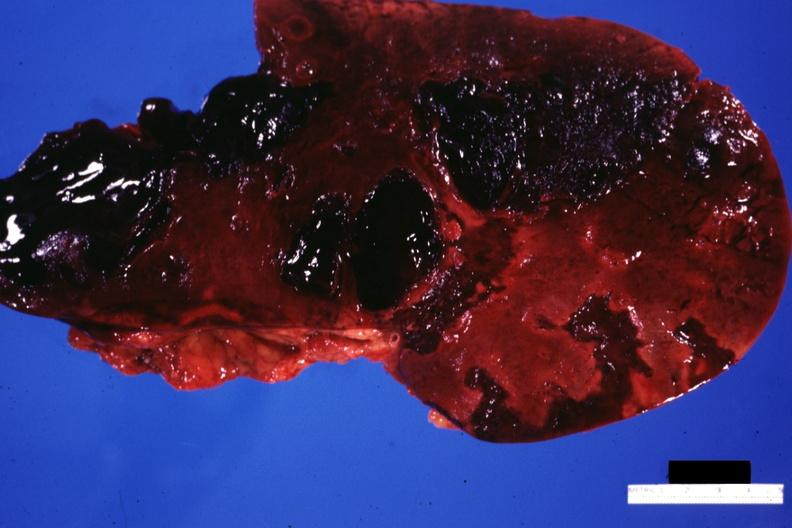what is present?
Answer the question using a single word or phrase. Liver 